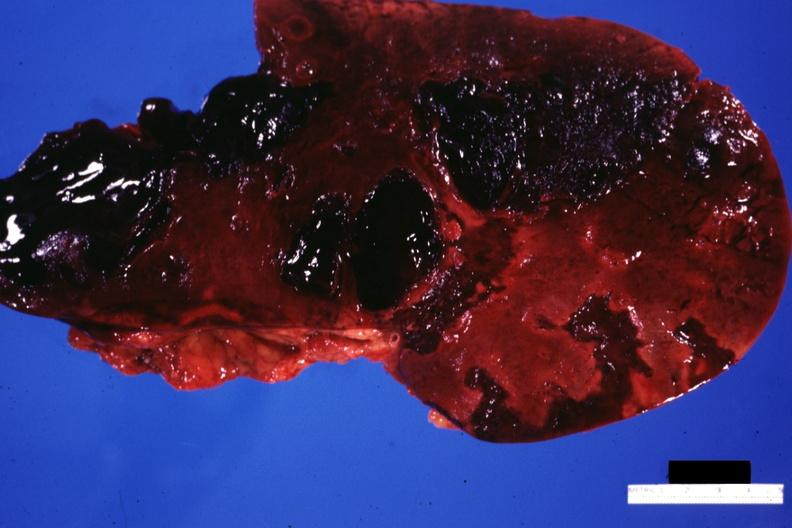what is present?
Answer the question using a single word or phrase. Liver 